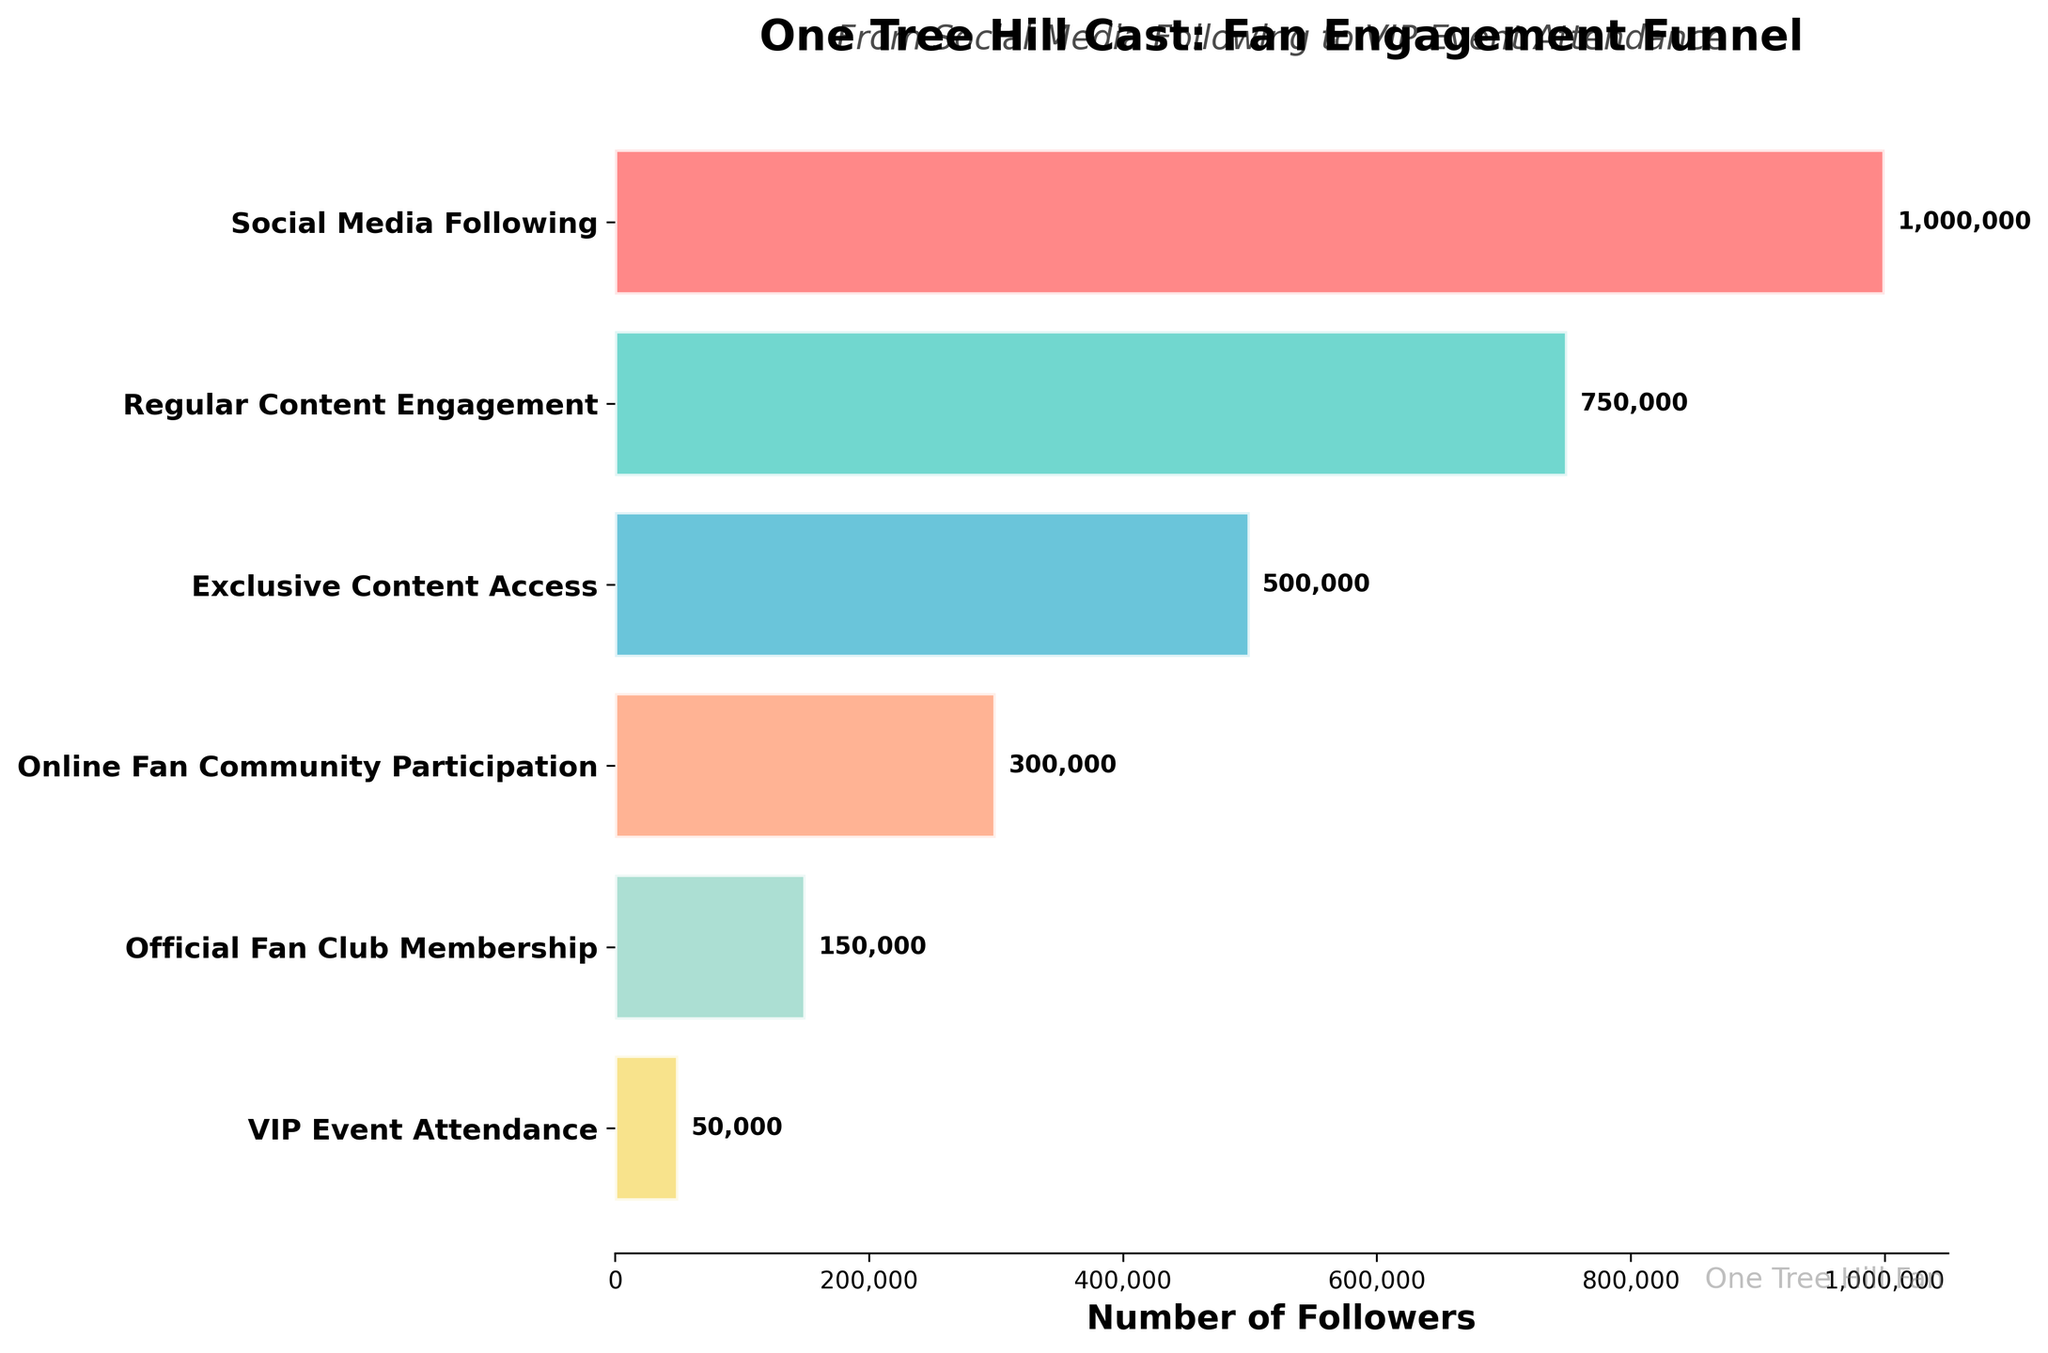What's the title of the funnel chart? The title is usually located at the top of the figure. For this plot, it's "One Tree Hill Cast: Fan Engagement Funnel".
Answer: One Tree Hill Cast: Fan Engagement Funnel Which stage has the highest number of followers? Stages are listed vertically, and the length of the horizontal bars represents the number of followers. The longest bar corresponds to the stage "Social Media Following".
Answer: Social Media Following How many followers engage with regular content? To find the number of followers at each stage, look at the labels placed at the end of the horizontal bars. For "Regular Content Engagement", it shows 750,000 followers.
Answer: 750,000 What is the difference in the number of followers between the "Exclusive Content Access" stage and the "Online Fan Community Participation" stage? Subtract the number of followers at the "Online Fan Community Participation" stage (300,000) from the number at the "Exclusive Content Access" stage (500,000).
Answer: 200,000 How many stages are depicted in this funnel chart? Count the number of unique stages listed on the y-axis. There are six stages in total.
Answer: 6 Which stage shows the most significant drop in the number of followers compared to the previous stage? Compare the differences between successive stages. The largest drop is between "Official Fan Club Membership" (150,000) and "VIP Event Attendance" (50,000), a drop of 100,000 followers.
Answer: Official Fan Club Membership to VIP Event Attendance What percentage of the initial "Social Media Following" remains as "VIP Event Attendance"? Calculate the percentage: (50,000 / 1,000,000) * 100% = 5%.
Answer: 5% Which stage has half the number of followers compared to the "Exclusive Content Access" stage? The "Official Fan Club Membership" stage has 150,000 followers, which is half of the "Exclusive Content Access" stage with 500,000 followers.
Answer: Official Fan Club Membership Are there any stages where follower numbers are exactly one-third of the "Online Fan Community Participation" stage? Calculate one-third of "Online Fan Community Participation" stage followers: 300,000 / 3 = 100,000. No stage has exactly 100,000 followers.
Answer: No What are the color patterns utilized in representing the different stages? The bars are colored: '#FF6B6B' (red), '#4ECDC4' (teal), '#45B7D1' (blue), '#FFA07A' (light salmon), '#98D8C8' (mint), and '#F7DC6F' (yellow).
Answer: Red, teal, blue, light salmon, mint, yellow 